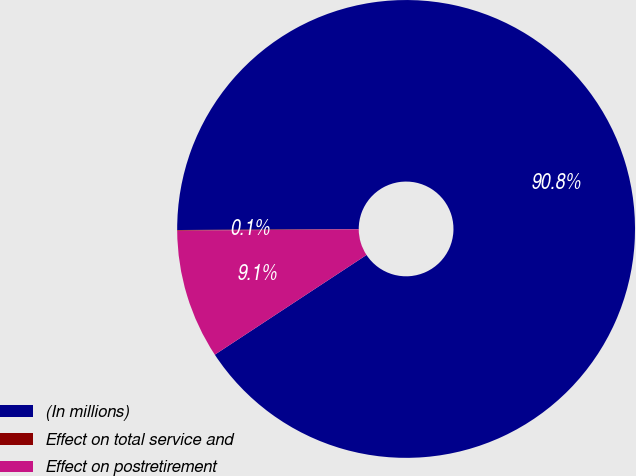Convert chart to OTSL. <chart><loc_0><loc_0><loc_500><loc_500><pie_chart><fcel>(In millions)<fcel>Effect on total service and<fcel>Effect on postretirement<nl><fcel>90.82%<fcel>0.05%<fcel>9.13%<nl></chart> 